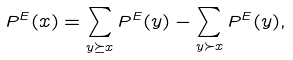Convert formula to latex. <formula><loc_0><loc_0><loc_500><loc_500>P ^ { E } ( x ) = \sum _ { y \succeq x } P ^ { E } ( y ) - \sum _ { y \succ x } P ^ { E } ( y ) ,</formula> 